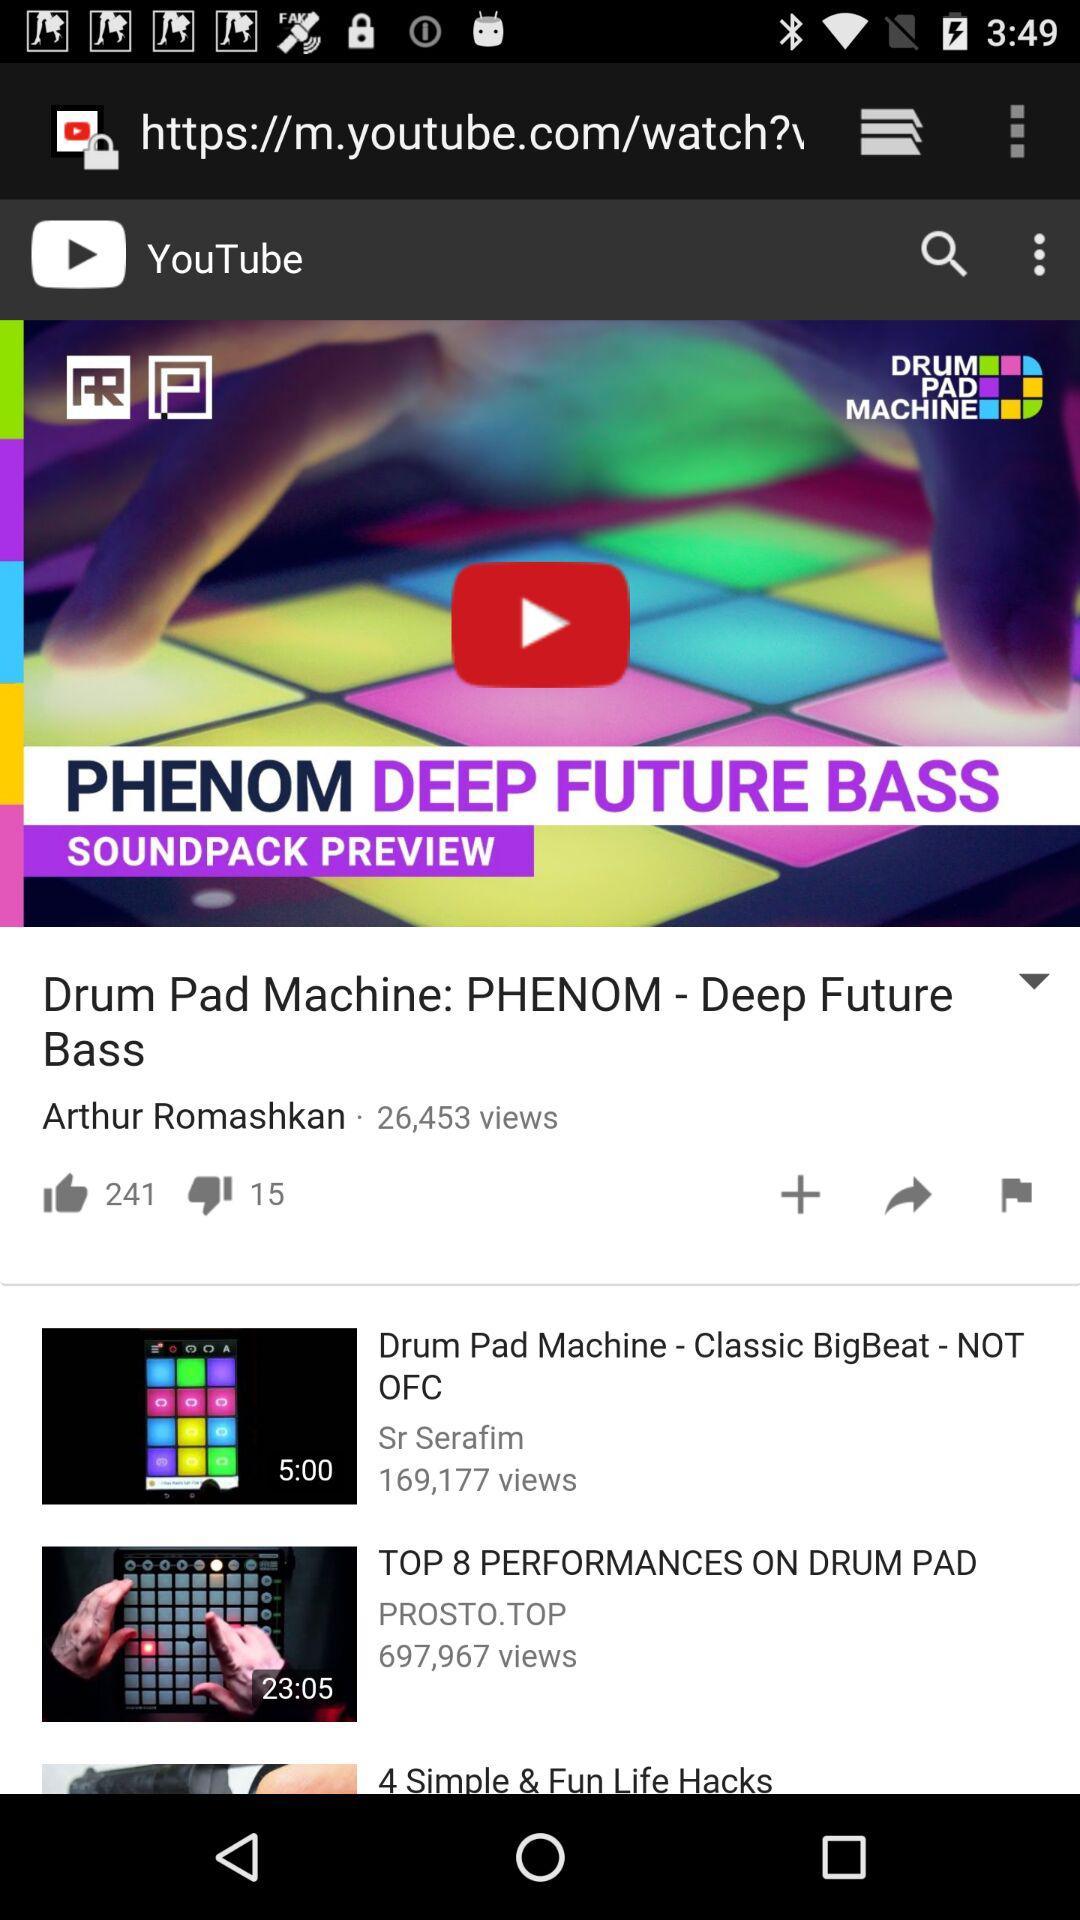How many people have liked "Drum Pad Machine: PHENOM - Deep Future Bass"? It is liked by 241 people. 